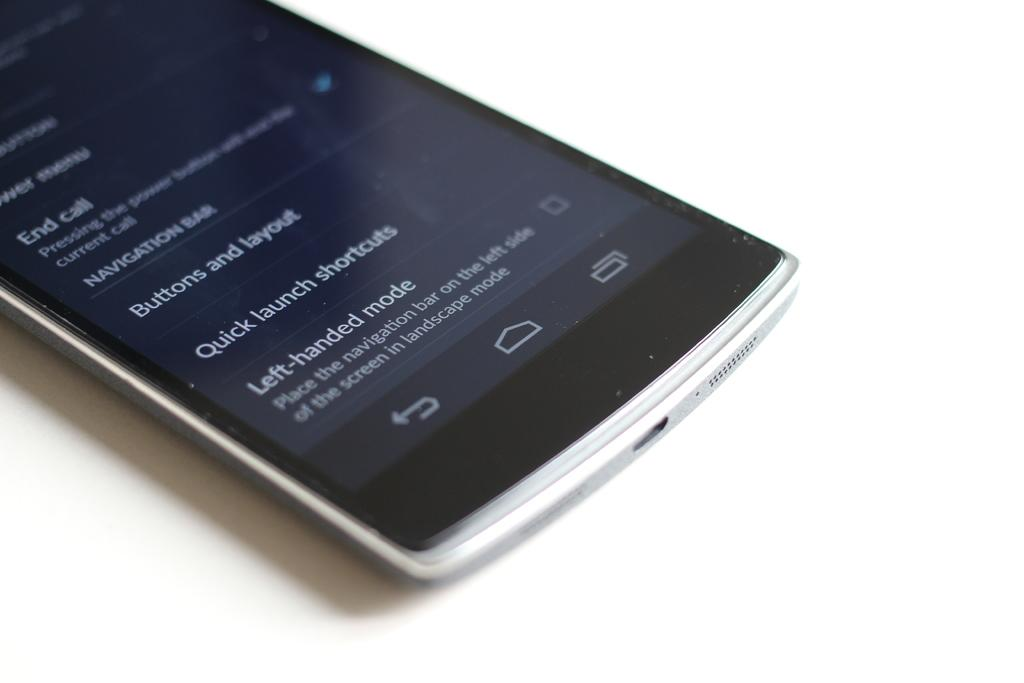Provide a one-sentence caption for the provided image. A cell phone with the words quick launch shortcuts and left handed mode on the bottom of the screen. 